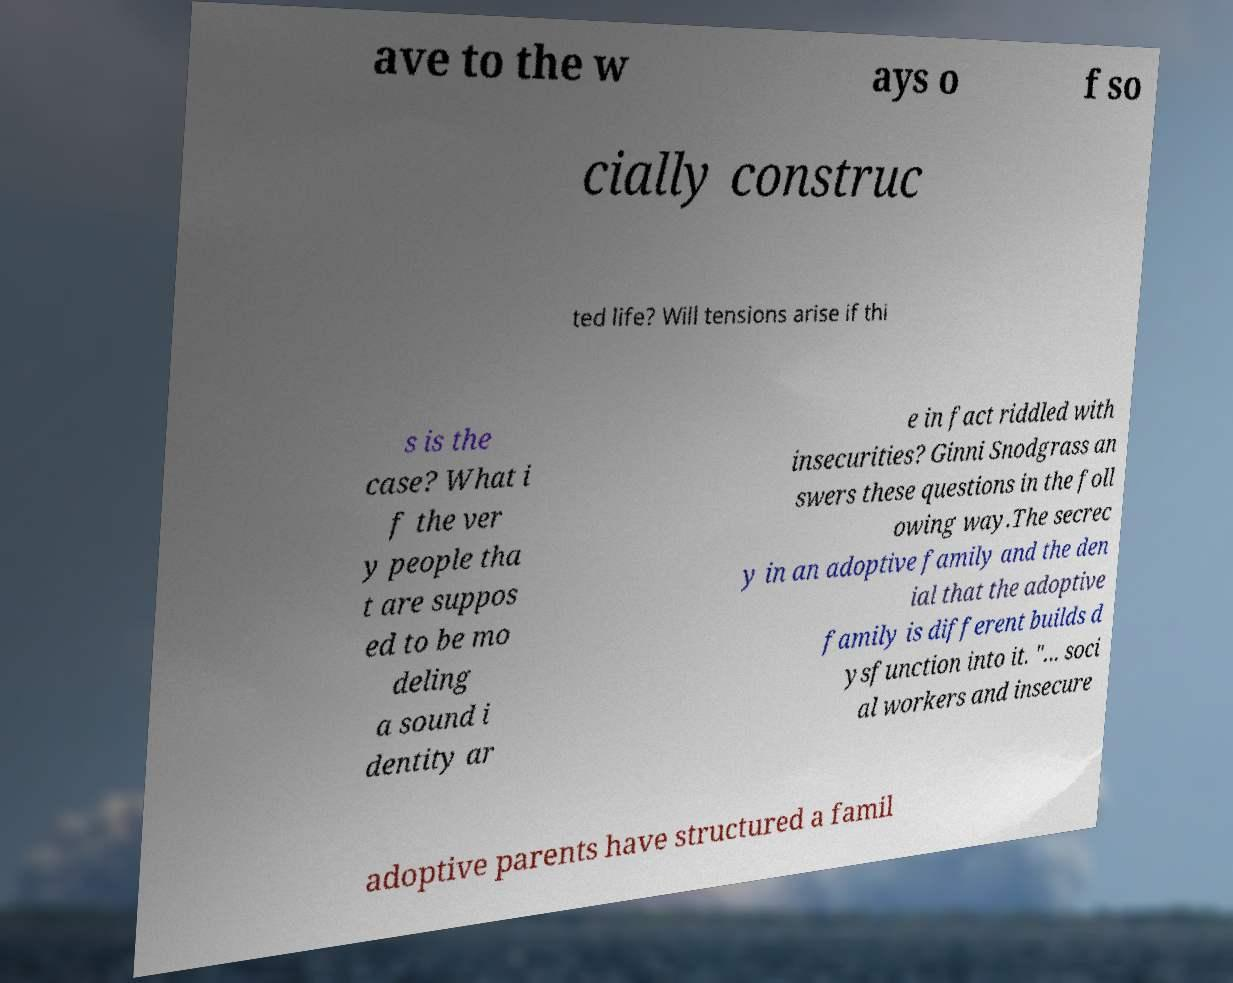For documentation purposes, I need the text within this image transcribed. Could you provide that? ave to the w ays o f so cially construc ted life? Will tensions arise if thi s is the case? What i f the ver y people tha t are suppos ed to be mo deling a sound i dentity ar e in fact riddled with insecurities? Ginni Snodgrass an swers these questions in the foll owing way.The secrec y in an adoptive family and the den ial that the adoptive family is different builds d ysfunction into it. "... soci al workers and insecure adoptive parents have structured a famil 